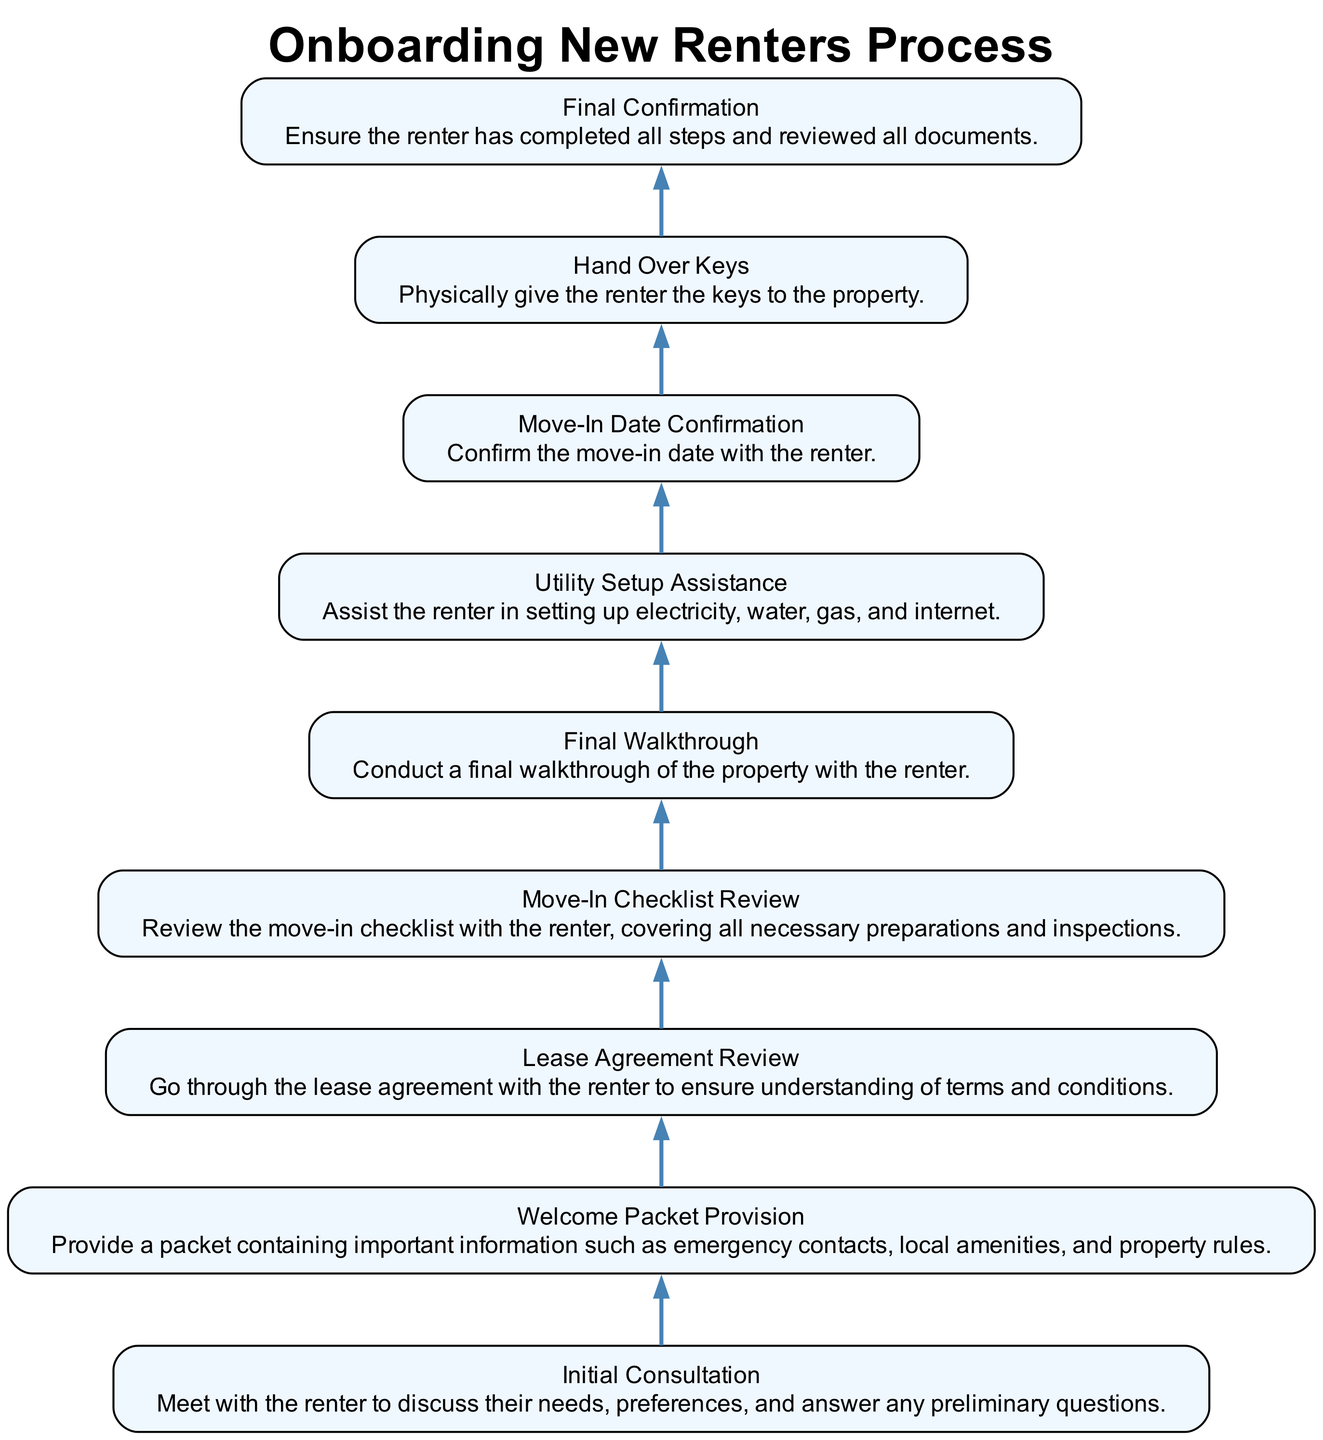What is the first step in the onboarding process? The first step in the onboarding process is "Initial Consultation." This step has no dependencies, meaning it is the starting point of the sequence.
Answer: Initial Consultation How many steps are there in the diagram? By counting each step defined in the data under 'elements,' there are a total of eight distinct steps in the onboarding process.
Answer: 8 Which step comes directly before "Hand Over Keys"? The step that comes directly before "Hand Over Keys" is "Move-In Date Confirmation." The diagram shows that "Hand Over Keys" depends on "Move-In Date Confirmation."
Answer: Move-In Date Confirmation What is the relationship between "Lease Agreement Review" and "Move-In Checklist Review"? "Lease Agreement Review" is a prerequisite for "Move-In Checklist Review," as indicated in the dependencies. This means the lease agreement must be reviewed before the checklist can be addressed.
Answer: Lease Agreement Review depends on Move-In Checklist Review What is the final step in the onboarding process? The final step in the onboarding process is "Final Confirmation," which ensures that all prior steps have been completed. This step wraps up the onboarding activities.
Answer: Final Confirmation Which step provides important information like emergency contacts? "Welcome Packet Provision" is the step that provides important information, including emergency contacts, local amenities, and property rules, as stated in its description.
Answer: Welcome Packet Provision What is the purpose of the "Utility Setup Assistance" step? The "Utility Setup Assistance" step's purpose is to help the renter set up essential utilities such as electricity, water, gas, and internet, ensuring they have the necessary services upon moving in.
Answer: Assist the renter in setting up utilities What must happen before conducting the "Final Walkthrough"? Before conducting the "Final Walkthrough," the "Move-In Checklist Review" must be completed. The diagram indicates that this review is a prerequisite for the walkthrough.
Answer: Move-In Checklist Review 